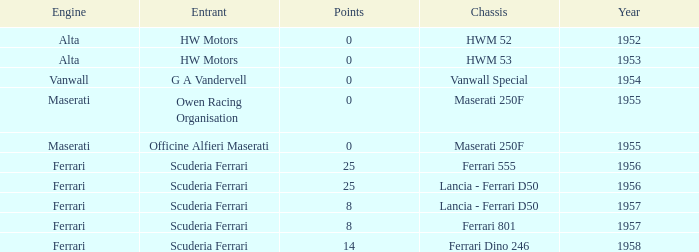What company made the chassis when there were 8 points? Lancia - Ferrari D50, Ferrari 801. Would you mind parsing the complete table? {'header': ['Engine', 'Entrant', 'Points', 'Chassis', 'Year'], 'rows': [['Alta', 'HW Motors', '0', 'HWM 52', '1952'], ['Alta', 'HW Motors', '0', 'HWM 53', '1953'], ['Vanwall', 'G A Vandervell', '0', 'Vanwall Special', '1954'], ['Maserati', 'Owen Racing Organisation', '0', 'Maserati 250F', '1955'], ['Maserati', 'Officine Alfieri Maserati', '0', 'Maserati 250F', '1955'], ['Ferrari', 'Scuderia Ferrari', '25', 'Ferrari 555', '1956'], ['Ferrari', 'Scuderia Ferrari', '25', 'Lancia - Ferrari D50', '1956'], ['Ferrari', 'Scuderia Ferrari', '8', 'Lancia - Ferrari D50', '1957'], ['Ferrari', 'Scuderia Ferrari', '8', 'Ferrari 801', '1957'], ['Ferrari', 'Scuderia Ferrari', '14', 'Ferrari Dino 246', '1958']]} 